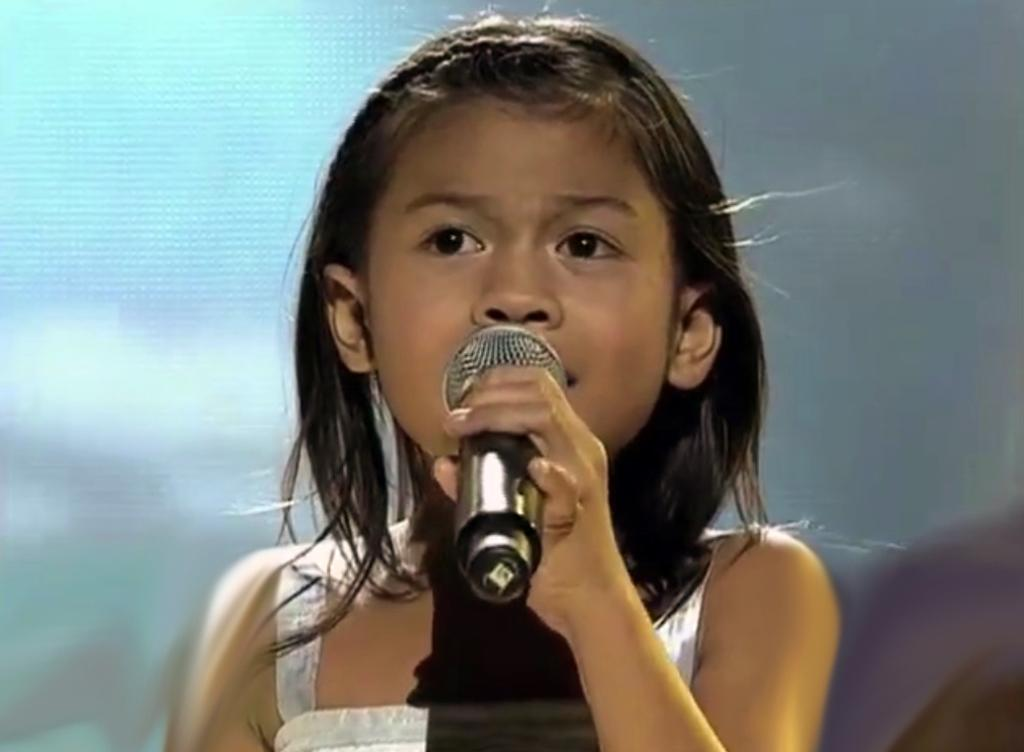What is the main subject of the image? The main subject of the image is a small girl. What is the girl holding in the image? The girl is holding a microphone in the image. What is the girl doing with the microphone? The girl is singing while holding the microphone. Does the girl have a brother playing with a stick in the image? There is no information about a brother or a stick in the image; it only shows the girl holding a microphone and singing. 